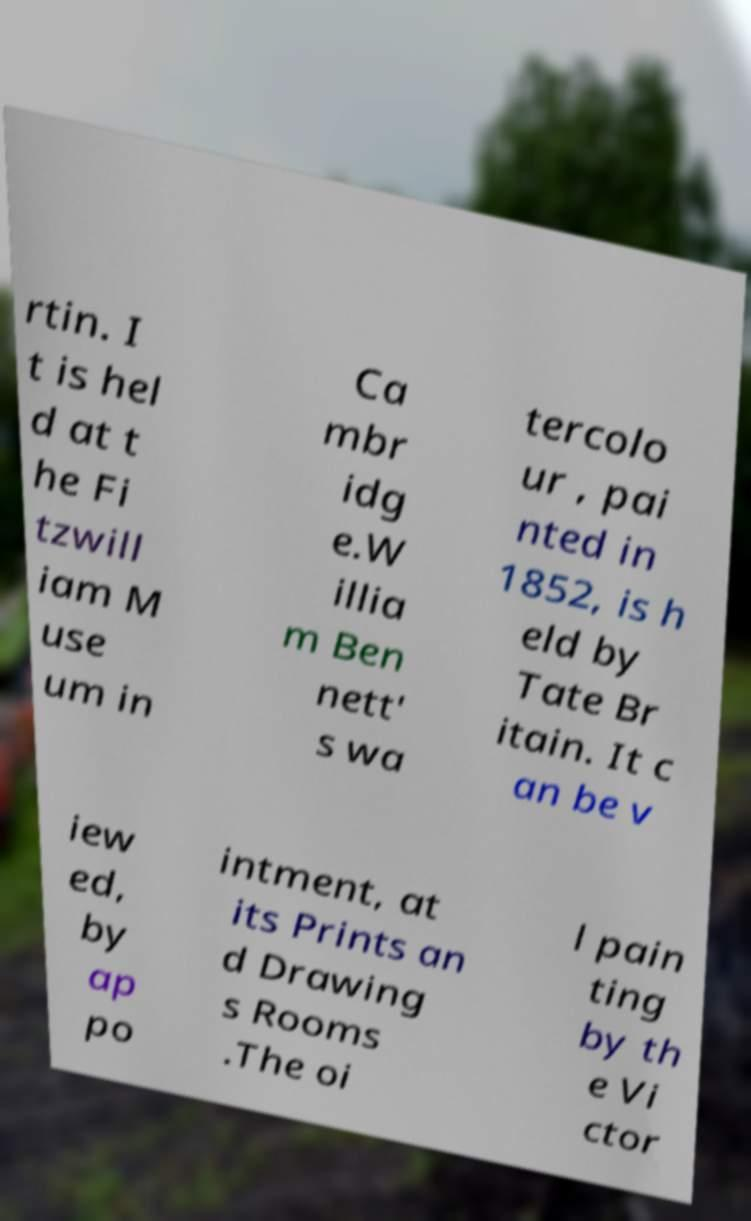I need the written content from this picture converted into text. Can you do that? rtin. I t is hel d at t he Fi tzwill iam M use um in Ca mbr idg e.W illia m Ben nett' s wa tercolo ur , pai nted in 1852, is h eld by Tate Br itain. It c an be v iew ed, by ap po intment, at its Prints an d Drawing s Rooms .The oi l pain ting by th e Vi ctor 